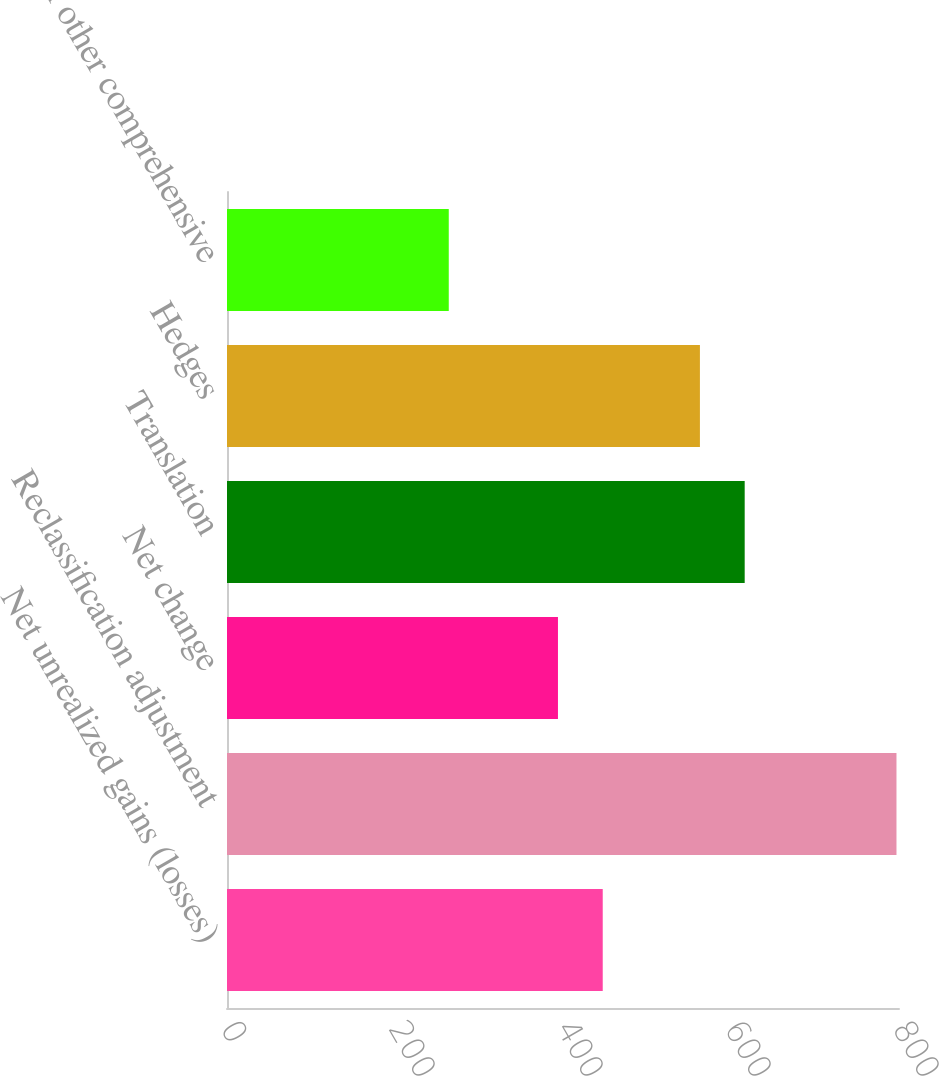<chart> <loc_0><loc_0><loc_500><loc_500><bar_chart><fcel>Net unrealized gains (losses)<fcel>Reclassification adjustment<fcel>Net change<fcel>Translation<fcel>Hedges<fcel>Total other comprehensive<nl><fcel>447.3<fcel>797<fcel>394<fcel>616.3<fcel>563<fcel>264<nl></chart> 